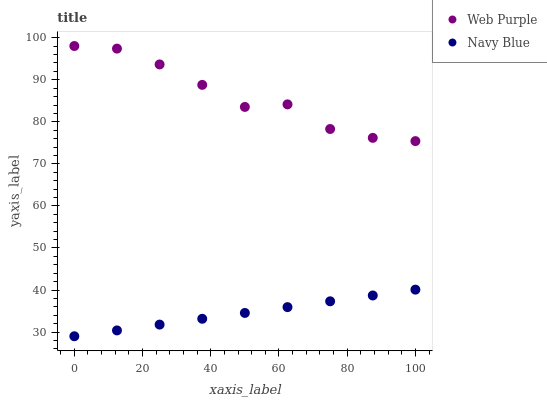Does Navy Blue have the minimum area under the curve?
Answer yes or no. Yes. Does Web Purple have the maximum area under the curve?
Answer yes or no. Yes. Does Web Purple have the minimum area under the curve?
Answer yes or no. No. Is Navy Blue the smoothest?
Answer yes or no. Yes. Is Web Purple the roughest?
Answer yes or no. Yes. Is Web Purple the smoothest?
Answer yes or no. No. Does Navy Blue have the lowest value?
Answer yes or no. Yes. Does Web Purple have the lowest value?
Answer yes or no. No. Does Web Purple have the highest value?
Answer yes or no. Yes. Is Navy Blue less than Web Purple?
Answer yes or no. Yes. Is Web Purple greater than Navy Blue?
Answer yes or no. Yes. Does Navy Blue intersect Web Purple?
Answer yes or no. No. 